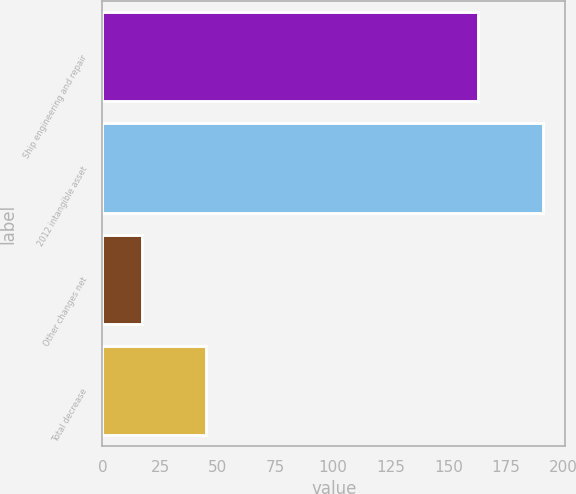Convert chart. <chart><loc_0><loc_0><loc_500><loc_500><bar_chart><fcel>Ship engineering and repair<fcel>2012 intangible asset<fcel>Other changes net<fcel>Total decrease<nl><fcel>163<fcel>191<fcel>17<fcel>45<nl></chart> 